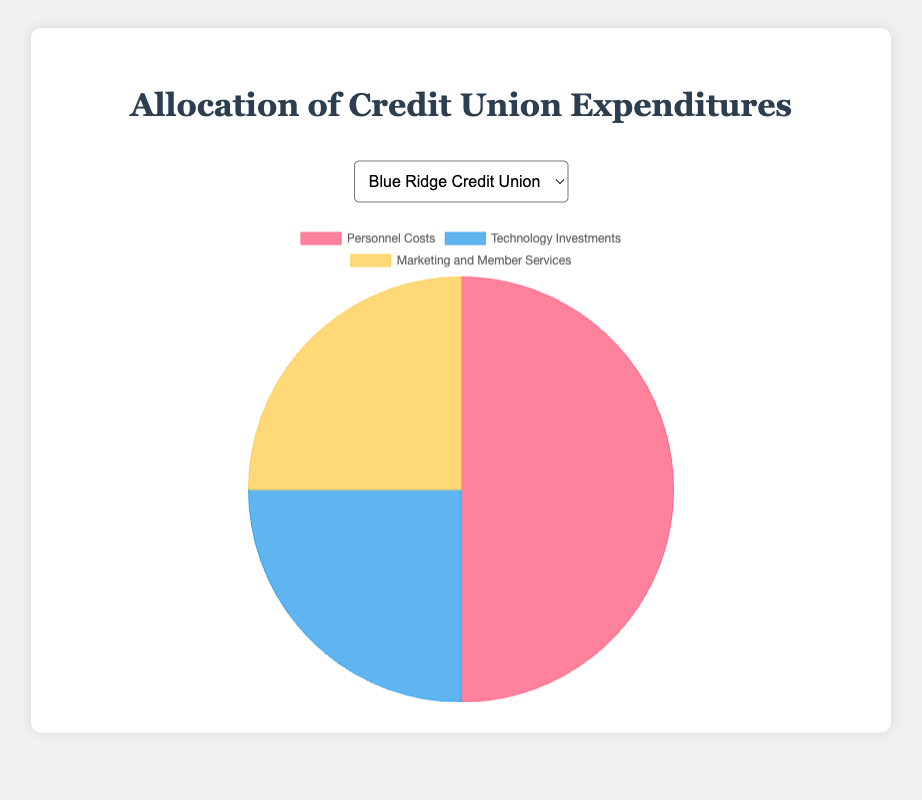What percentage of expenditures does Blue Ridge Credit Union allocate to Personnel Costs and Marketing and Member Services combined? To find the combined percentage, add the Personnel Costs (50%) and Marketing and Member Services (25%) percentages: 50 + 25 = 75
Answer: 75% Which credit union spends the most on Technology Investments? Compare the Technology Investments percentages of each credit union: Blue Ridge Credit Union (25%), Pine Valley Credit Union (30%), Riverbank Credit Union (20%). Pine Valley Credit Union has the highest percentage.
Answer: Pine Valley Credit Union Is the expenditure on Marketing and Member Services equal across all three credit unions? Check the Marketing and Member Services percentages for all three credit unions: Blue Ridge Credit Union (25%), Pine Valley Credit Union (25%), Riverbank Credit Union (25%). They are all equal.
Answer: Yes What is the difference in expenditure on Personnel Costs between Blue Ridge Credit Union and Riverbank Credit Union? Subtract Blue Ridge Credit Union's Personnel Costs percentage (50%) from Riverbank Credit Union's (55%): 55 - 50 = 5
Answer: 5% Which expenditure category has the same percentage allocation across all three credit unions? Compare the percentages for each category across all credit unions: Personnel Costs (50, 45, 55), Technology Investments (25, 30, 20), Marketing and Member Services (25, 25, 25). Only Marketing and Member Services is the same at 25%.
Answer: Marketing and Member Services How much more does Pine Valley Credit Union spend on Technology Investments compared to Blue Ridge Credit Union? Subtract Blue Ridge Credit Union's Technology Investments percentage (25%) from Pine Valley Credit Union's (30%): 30 - 25 = 5
Answer: 5% If all credit union expenditures percentages are combined, which category has the highest total percentage? Add up the percentages for each category across all credit unions:
Personnel Costs: 50 + 45 + 55 = 150
Technology Investments: 25 + 30 + 20 = 75
Marketing and Member Services: 25 + 25 + 25 = 75
Personnel Costs have the highest combined percentage of 150
Answer: Personnel Costs What is the total percentage of expenditure on Personnel Costs and Technology Investments for Riverbank Credit Union? Add the percentages for Personnel Costs (55%) and Technology Investments (20%) for Riverbank Credit Union: 55 + 20 = 75
Answer: 75% Between Blue Ridge and Pine Valley Credit Union, which one has a lower percentage spent on Marketing and Member Services? Compare the Marketing and Member Services percentages: Blue Ridge Credit Union (25%), Pine Valley Credit Union (25%). Both have the same percentage spent on Marketing and Member Services.
Answer: Neither Which credit union spends less on Personnel Costs than it does on Technology Investments? Compare the Personnel Costs and Technology Investments percentages for each credit union: 
Blue Ridge Credit Union: Personnel (50%) > Technology (25%)
Pine Valley Credit Union: Personnel (45%) > Technology (30%)
Riverbank Credit Union: Personnel (55%) > Technology (20%)
None of the credit unions spend less on Personnel Costs than on Technology Investments.
Answer: None 